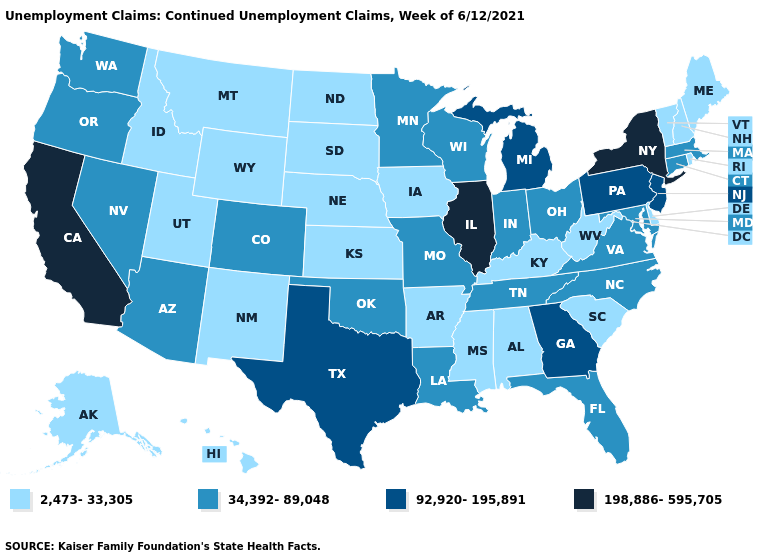Name the states that have a value in the range 34,392-89,048?
Concise answer only. Arizona, Colorado, Connecticut, Florida, Indiana, Louisiana, Maryland, Massachusetts, Minnesota, Missouri, Nevada, North Carolina, Ohio, Oklahoma, Oregon, Tennessee, Virginia, Washington, Wisconsin. Does Alabama have a higher value than Iowa?
Concise answer only. No. Does West Virginia have the same value as Ohio?
Quick response, please. No. Among the states that border North Carolina , does Georgia have the lowest value?
Give a very brief answer. No. Which states hav the highest value in the Northeast?
Write a very short answer. New York. Does the first symbol in the legend represent the smallest category?
Quick response, please. Yes. Does Minnesota have the highest value in the MidWest?
Quick response, please. No. Does Maryland have a lower value than Washington?
Concise answer only. No. Among the states that border Arizona , which have the highest value?
Give a very brief answer. California. Name the states that have a value in the range 2,473-33,305?
Be succinct. Alabama, Alaska, Arkansas, Delaware, Hawaii, Idaho, Iowa, Kansas, Kentucky, Maine, Mississippi, Montana, Nebraska, New Hampshire, New Mexico, North Dakota, Rhode Island, South Carolina, South Dakota, Utah, Vermont, West Virginia, Wyoming. Which states have the lowest value in the USA?
Short answer required. Alabama, Alaska, Arkansas, Delaware, Hawaii, Idaho, Iowa, Kansas, Kentucky, Maine, Mississippi, Montana, Nebraska, New Hampshire, New Mexico, North Dakota, Rhode Island, South Carolina, South Dakota, Utah, Vermont, West Virginia, Wyoming. What is the value of Alaska?
Give a very brief answer. 2,473-33,305. Name the states that have a value in the range 198,886-595,705?
Short answer required. California, Illinois, New York. Which states have the lowest value in the West?
Give a very brief answer. Alaska, Hawaii, Idaho, Montana, New Mexico, Utah, Wyoming. 